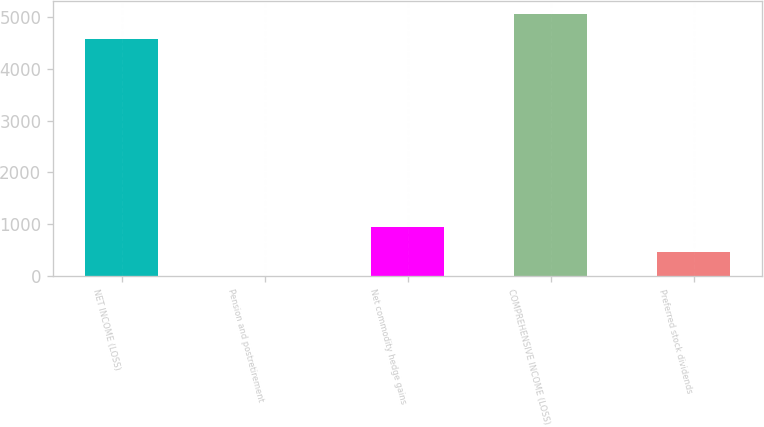Convert chart to OTSL. <chart><loc_0><loc_0><loc_500><loc_500><bar_chart><fcel>NET INCOME (LOSS)<fcel>Pension and postretirement<fcel>Net commodity hedge gains<fcel>COMPREHENSIVE INCOME (LOSS)<fcel>Preferred stock dividends<nl><fcel>4584<fcel>1<fcel>944<fcel>5055.5<fcel>472.5<nl></chart> 